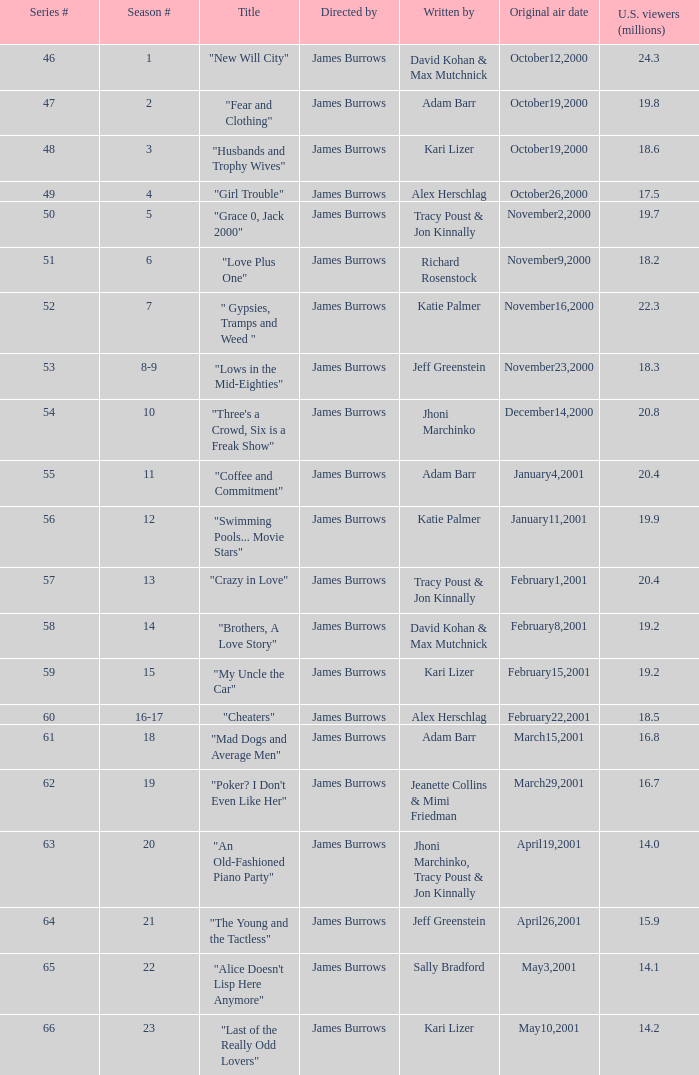Who wrote the episode titled "An Old-fashioned Piano Party"? Jhoni Marchinko, Tracy Poust & Jon Kinnally. 